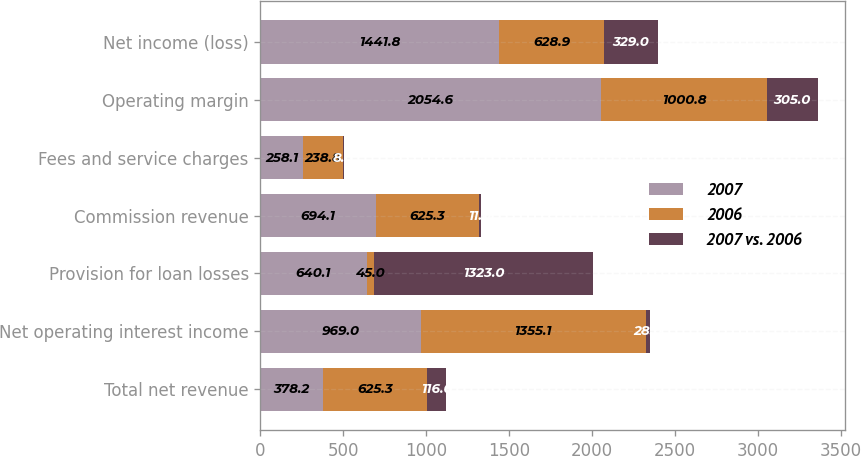<chart> <loc_0><loc_0><loc_500><loc_500><stacked_bar_chart><ecel><fcel>Total net revenue<fcel>Net operating interest income<fcel>Provision for loan losses<fcel>Commission revenue<fcel>Fees and service charges<fcel>Operating margin<fcel>Net income (loss)<nl><fcel>2007<fcel>378.2<fcel>969<fcel>640.1<fcel>694.1<fcel>258.1<fcel>2054.6<fcel>1441.8<nl><fcel>2006<fcel>625.3<fcel>1355.1<fcel>45<fcel>625.3<fcel>238.8<fcel>1000.8<fcel>628.9<nl><fcel>2007 vs. 2006<fcel>116<fcel>28<fcel>1323<fcel>11<fcel>8<fcel>305<fcel>329<nl></chart> 